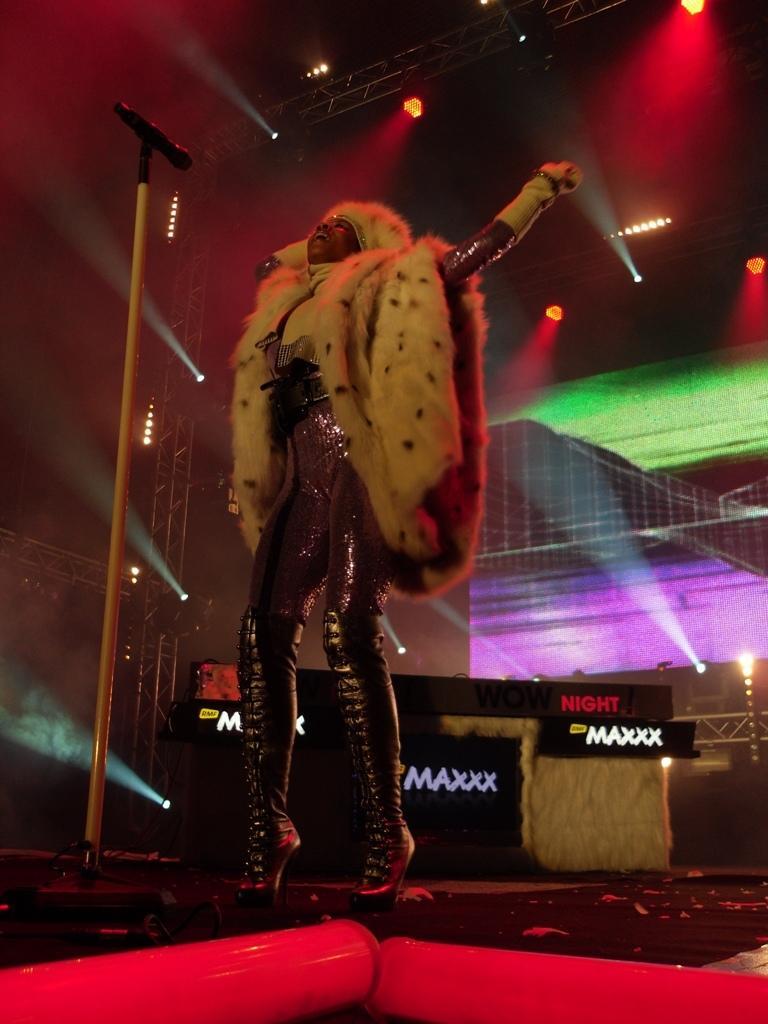In one or two sentences, can you explain what this image depicts? In this image I can see a woman standing near the mike. At the top I can see the lights. 